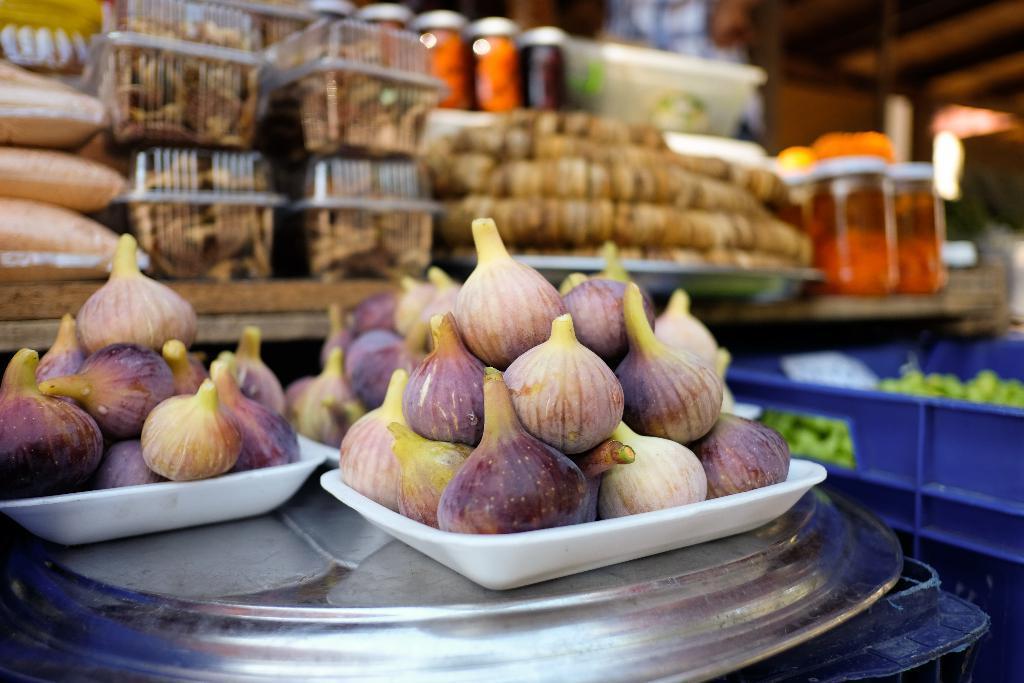Can you describe this image briefly? In this image we can see vegetables in three plates. These plates are placed on a single plate. Behind the vegetables we can see a group of objects on a table. On the right side of the image we can see a blue object and in the blue object we can see a group of objects. 